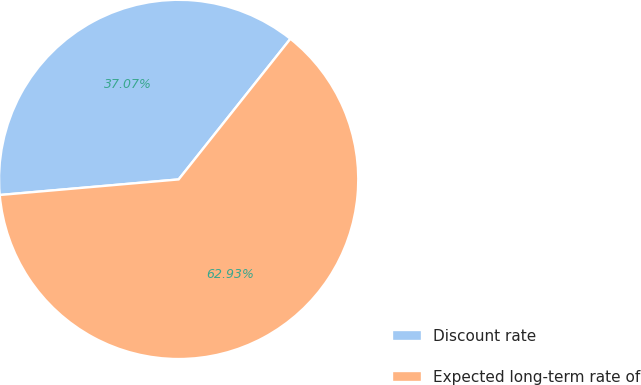Convert chart. <chart><loc_0><loc_0><loc_500><loc_500><pie_chart><fcel>Discount rate<fcel>Expected long-term rate of<nl><fcel>37.07%<fcel>62.93%<nl></chart> 